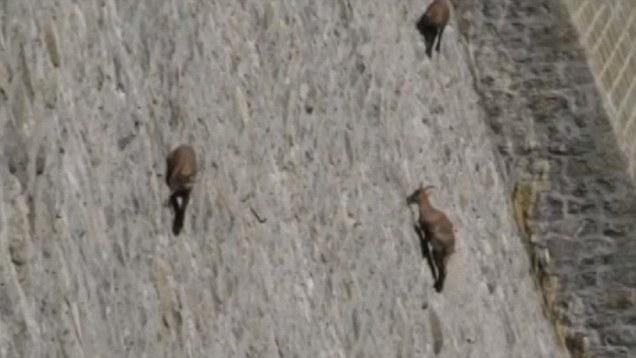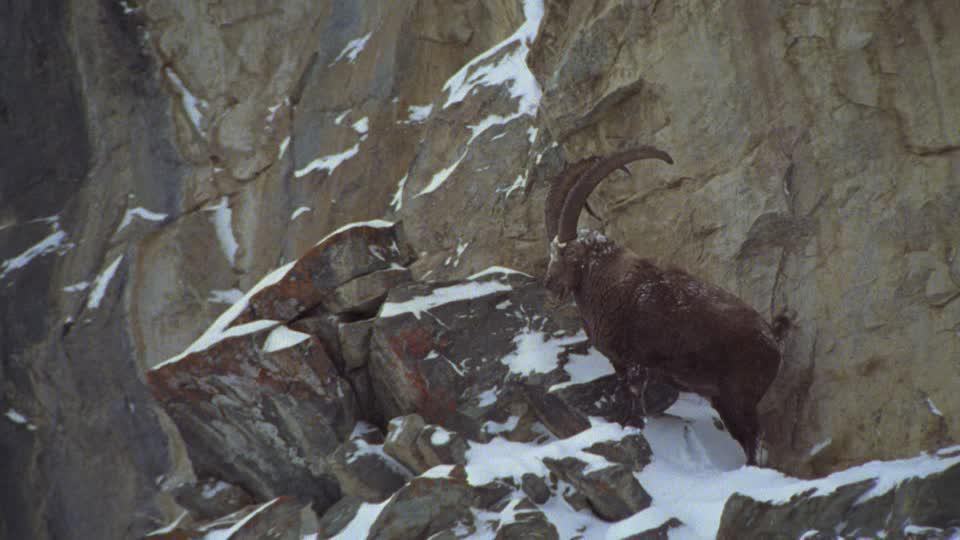The first image is the image on the left, the second image is the image on the right. For the images shown, is this caption "There are six mountain goats." true? Answer yes or no. No. 